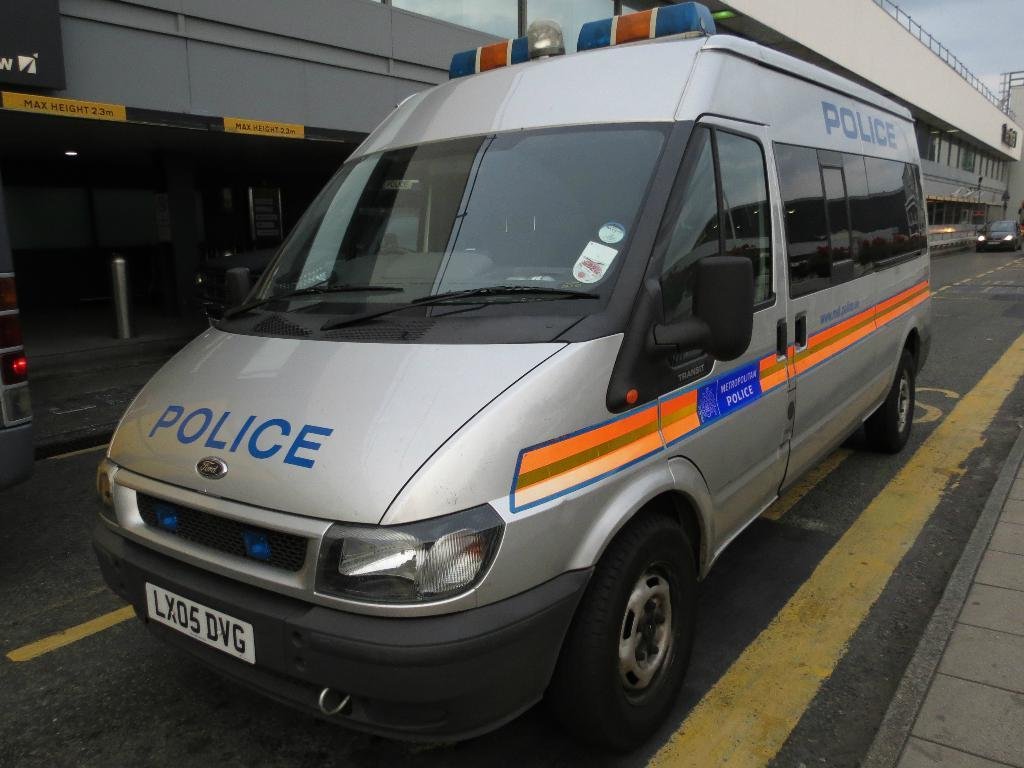<image>
Offer a succinct explanation of the picture presented. A silver police van is painted with orange stripes. 